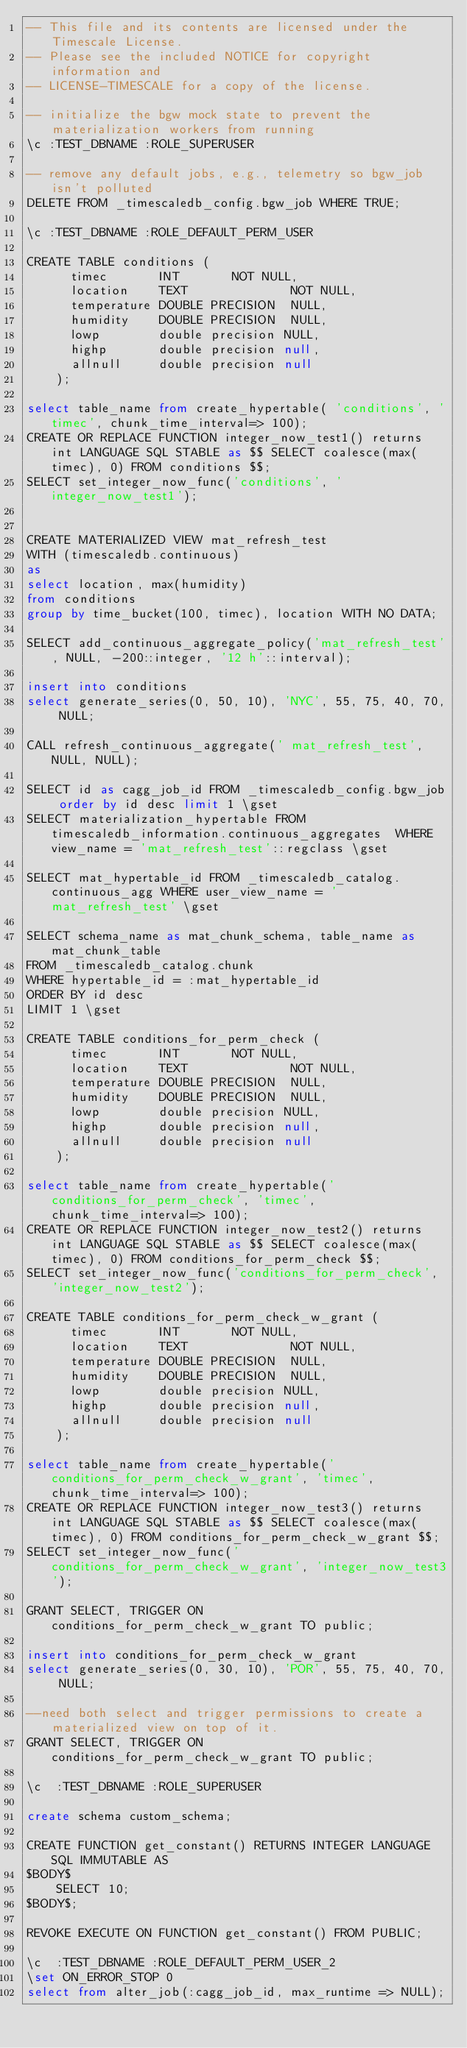Convert code to text. <code><loc_0><loc_0><loc_500><loc_500><_SQL_>-- This file and its contents are licensed under the Timescale License.
-- Please see the included NOTICE for copyright information and
-- LICENSE-TIMESCALE for a copy of the license.

-- initialize the bgw mock state to prevent the materialization workers from running
\c :TEST_DBNAME :ROLE_SUPERUSER

-- remove any default jobs, e.g., telemetry so bgw_job isn't polluted
DELETE FROM _timescaledb_config.bgw_job WHERE TRUE;

\c :TEST_DBNAME :ROLE_DEFAULT_PERM_USER

CREATE TABLE conditions (
      timec       INT       NOT NULL,
      location    TEXT              NOT NULL,
      temperature DOUBLE PRECISION  NULL,
      humidity    DOUBLE PRECISION  NULL,
      lowp        double precision NULL,
      highp       double precision null,
      allnull     double precision null
    );

select table_name from create_hypertable( 'conditions', 'timec', chunk_time_interval=> 100);
CREATE OR REPLACE FUNCTION integer_now_test1() returns int LANGUAGE SQL STABLE as $$ SELECT coalesce(max(timec), 0) FROM conditions $$;
SELECT set_integer_now_func('conditions', 'integer_now_test1');


CREATE MATERIALIZED VIEW mat_refresh_test
WITH (timescaledb.continuous)
as
select location, max(humidity)
from conditions
group by time_bucket(100, timec), location WITH NO DATA;

SELECT add_continuous_aggregate_policy('mat_refresh_test', NULL, -200::integer, '12 h'::interval);

insert into conditions
select generate_series(0, 50, 10), 'NYC', 55, 75, 40, 70, NULL;

CALL refresh_continuous_aggregate(' mat_refresh_test', NULL, NULL);

SELECT id as cagg_job_id FROM _timescaledb_config.bgw_job order by id desc limit 1 \gset
SELECT materialization_hypertable FROM timescaledb_information.continuous_aggregates  WHERE view_name = 'mat_refresh_test'::regclass \gset

SELECT mat_hypertable_id FROM _timescaledb_catalog.continuous_agg WHERE user_view_name = 'mat_refresh_test' \gset

SELECT schema_name as mat_chunk_schema, table_name as mat_chunk_table
FROM _timescaledb_catalog.chunk
WHERE hypertable_id = :mat_hypertable_id
ORDER BY id desc
LIMIT 1 \gset

CREATE TABLE conditions_for_perm_check (
      timec       INT       NOT NULL,
      location    TEXT              NOT NULL,
      temperature DOUBLE PRECISION  NULL,
      humidity    DOUBLE PRECISION  NULL,
      lowp        double precision NULL,
      highp       double precision null,
      allnull     double precision null
    );

select table_name from create_hypertable('conditions_for_perm_check', 'timec', chunk_time_interval=> 100);
CREATE OR REPLACE FUNCTION integer_now_test2() returns int LANGUAGE SQL STABLE as $$ SELECT coalesce(max(timec), 0) FROM conditions_for_perm_check $$;
SELECT set_integer_now_func('conditions_for_perm_check', 'integer_now_test2');

CREATE TABLE conditions_for_perm_check_w_grant (
      timec       INT       NOT NULL,
      location    TEXT              NOT NULL,
      temperature DOUBLE PRECISION  NULL,
      humidity    DOUBLE PRECISION  NULL,
      lowp        double precision NULL,
      highp       double precision null,
      allnull     double precision null
    );

select table_name from create_hypertable('conditions_for_perm_check_w_grant', 'timec', chunk_time_interval=> 100);
CREATE OR REPLACE FUNCTION integer_now_test3() returns int LANGUAGE SQL STABLE as $$ SELECT coalesce(max(timec), 0) FROM conditions_for_perm_check_w_grant $$;
SELECT set_integer_now_func('conditions_for_perm_check_w_grant', 'integer_now_test3');

GRANT SELECT, TRIGGER ON conditions_for_perm_check_w_grant TO public;

insert into conditions_for_perm_check_w_grant
select generate_series(0, 30, 10), 'POR', 55, 75, 40, 70, NULL;

--need both select and trigger permissions to create a materialized view on top of it.
GRANT SELECT, TRIGGER ON conditions_for_perm_check_w_grant TO public;

\c  :TEST_DBNAME :ROLE_SUPERUSER

create schema custom_schema;

CREATE FUNCTION get_constant() RETURNS INTEGER LANGUAGE SQL IMMUTABLE AS
$BODY$
    SELECT 10;
$BODY$;

REVOKE EXECUTE ON FUNCTION get_constant() FROM PUBLIC;

\c  :TEST_DBNAME :ROLE_DEFAULT_PERM_USER_2
\set ON_ERROR_STOP 0
select from alter_job(:cagg_job_id, max_runtime => NULL);
</code> 